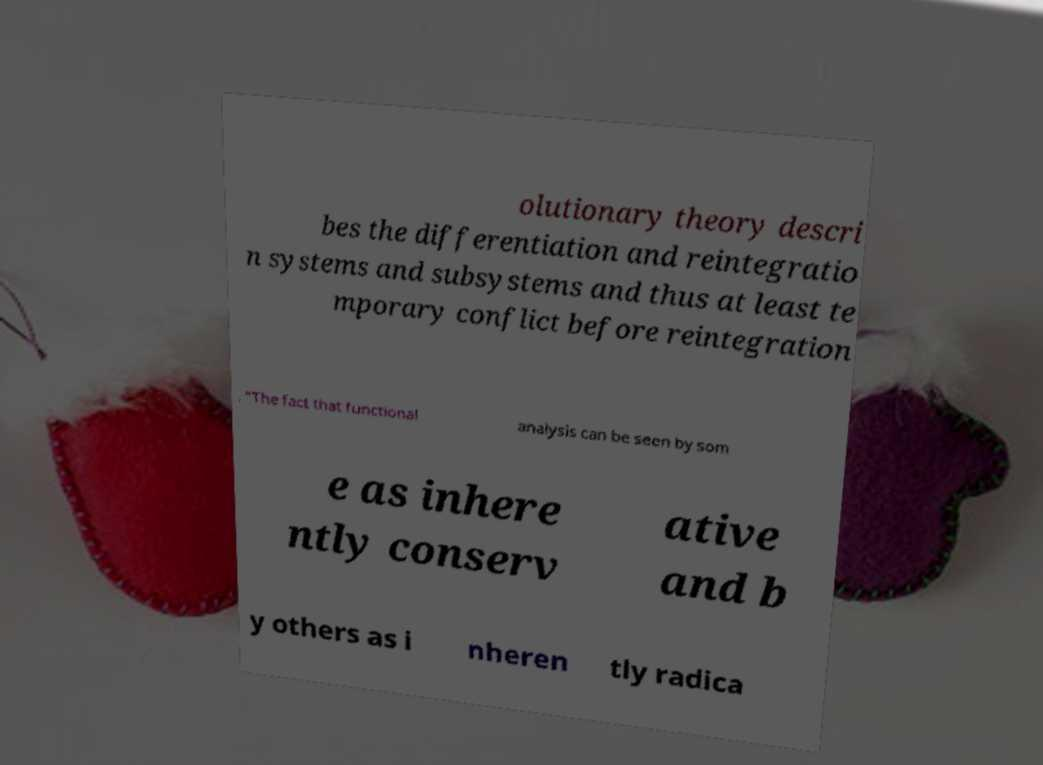Please identify and transcribe the text found in this image. olutionary theory descri bes the differentiation and reintegratio n systems and subsystems and thus at least te mporary conflict before reintegration . "The fact that functional analysis can be seen by som e as inhere ntly conserv ative and b y others as i nheren tly radica 